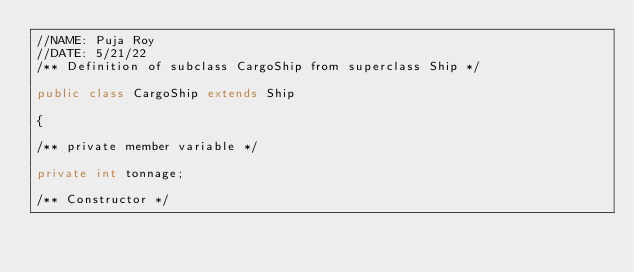Convert code to text. <code><loc_0><loc_0><loc_500><loc_500><_Java_>//NAME: Puja Roy
//DATE: 5/21/22
/** Definition of subclass CargoShip from superclass Ship */

public class CargoShip extends Ship

{

/** private member variable */

private int tonnage;

/** Constructor */
</code> 